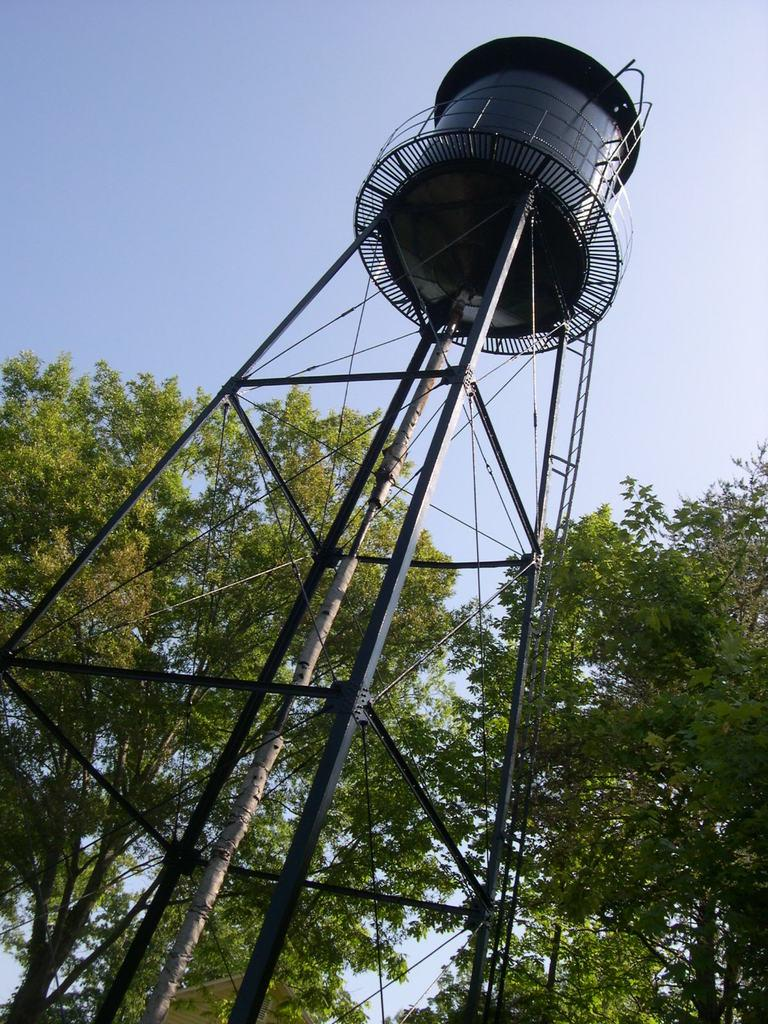What type of vegetation is present in the image? There are trees in the image. What is the large object in the image? There is a tank in the image. What is visible at the top of the image? The sky is visible at the top of the image. What type of grass is growing around the tank in the image? There is no grass visible in the image; only trees and a tank are present. What type of trucks can be seen in the image? There are no trucks present in the image. 